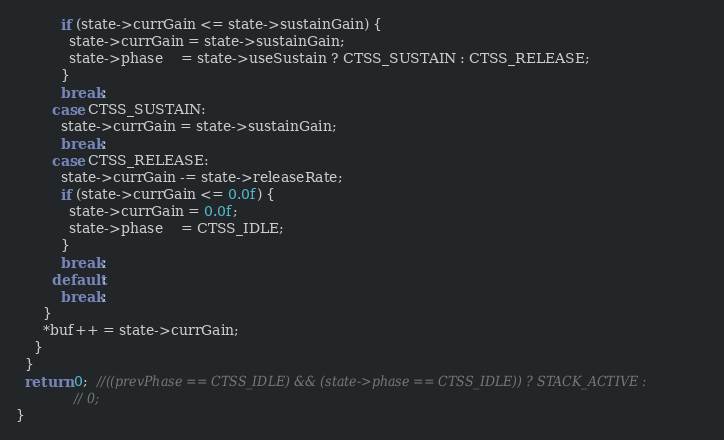<code> <loc_0><loc_0><loc_500><loc_500><_C_>          if (state->currGain <= state->sustainGain) {
            state->currGain = state->sustainGain;
            state->phase    = state->useSustain ? CTSS_SUSTAIN : CTSS_RELEASE;
          }
          break;
        case CTSS_SUSTAIN:
          state->currGain = state->sustainGain;
          break;
        case CTSS_RELEASE:
          state->currGain -= state->releaseRate;
          if (state->currGain <= 0.0f) {
            state->currGain = 0.0f;
            state->phase    = CTSS_IDLE;
          }
          break;
        default:
          break;
      }
      *buf++ = state->currGain;
    }
  }
  return 0;  //((prevPhase == CTSS_IDLE) && (state->phase == CTSS_IDLE)) ? STACK_ACTIVE :
             // 0;
}
</code> 